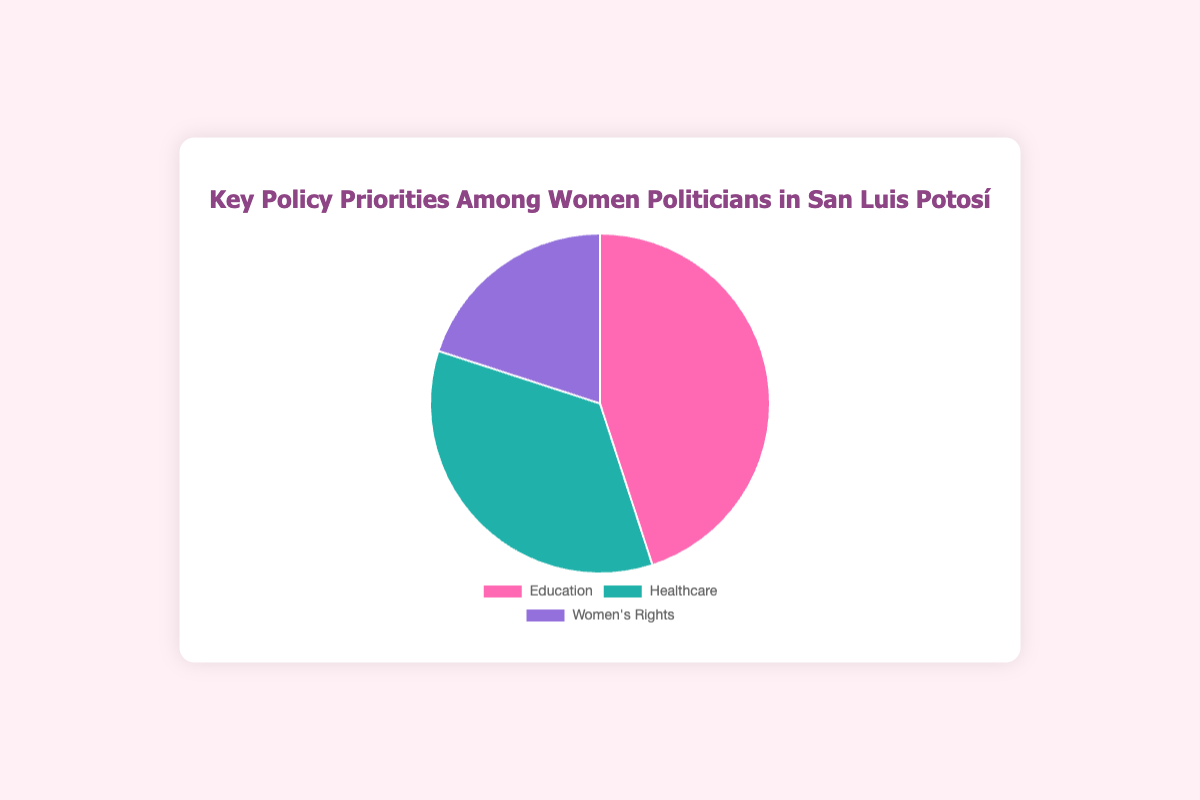What percentage of women politicians prioritize Education? The pie chart shows that the sector marked in pink color represents the percentage of women politicians focusing on Education. This proportion is given as 45%.
Answer: 45% Which policy priority has the least representation among women politicians in San Luis Potosí? By observing the pie chart, the smallest segment is associated with Women's Rights. This segment represents the lowest percentage.
Answer: Women's Rights What is the combined percentage of women politicians who prioritize Healthcare and Women's Rights? The pie chart shows that 35% prioritize Healthcare and 20% prioritize Women's Rights. Adding these two percentages (35 + 20) gives a combined total of 55%.
Answer: 55% Who is focusing on Women's Rights among the women politicians shown? Checking the tooltip information or pie chart labels, it's given that Women's Rights, marked in lavender color, is prioritized by María Guitrón López.
Answer: María Guitrón López How does the proportion of focus on Healthcare compare to that on Education? The pie chart shows that Healthcare is represented by 35%, while Education is represented by 45%. By comparing these percentages, Education has a higher focus.
Answer: Education has a higher focus Which policy priority is represented by the turquoise-colored segment? By looking at the pie chart colors and labels, the turquoise segment represents Healthcare, which is supported by 35% of the women politicians.
Answer: Healthcare What is the difference in the percentage of women politicians focusing on Education and those focusing on Women's Rights? The percentage for Education is 45% and for Women's Rights is 20%. The difference is calculated as 45 - 20, which equals 25%.
Answer: 25% Who prioritizes Education among the women politicians, and what percentage do they represent? Referring to the pie chart segments and the associated tooltip information, María Graciela Gaitán Díaz is shown to prioritize Education with a segment representing 45%.
Answer: María Graciela Gaitán Díaz, 45% What is the average percentage of women politicians across the three policy priorities? Adding the percentages (45 for Education, 35 for Healthcare, 20 for Women's Rights) gives 100. Dividing by the number of priorities (3) gives the average, 100 / 3 ≈ 33.33%.
Answer: ~33.33% Which two policy priorities combined exceed half of the total focus? From the pie chart, adding the percentages for Education (45%) and Healthcare (35%) gives 80%, which exceeds half (50%) of the total focus.
Answer: Education and Healthcare 